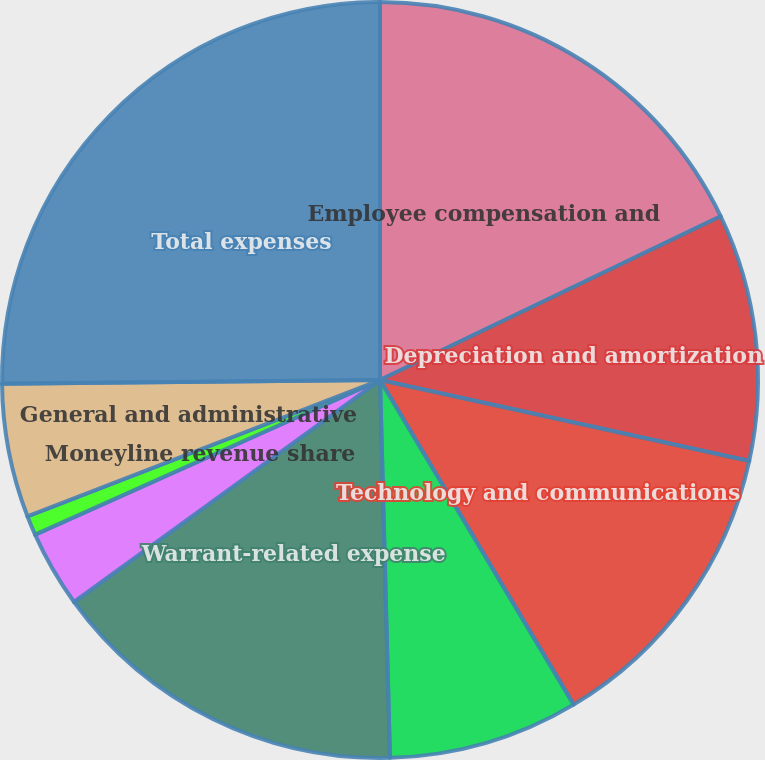Convert chart to OTSL. <chart><loc_0><loc_0><loc_500><loc_500><pie_chart><fcel>Employee compensation and<fcel>Depreciation and amortization<fcel>Technology and communications<fcel>Professional and consulting<fcel>Warrant-related expense<fcel>Marketing and advertising<fcel>Moneyline revenue share<fcel>General and administrative<fcel>Total expenses<nl><fcel>17.87%<fcel>10.57%<fcel>13.0%<fcel>8.14%<fcel>15.43%<fcel>3.28%<fcel>0.84%<fcel>5.71%<fcel>25.16%<nl></chart> 